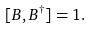Convert formula to latex. <formula><loc_0><loc_0><loc_500><loc_500>[ B , B ^ { \dagger } ] = 1 .</formula> 